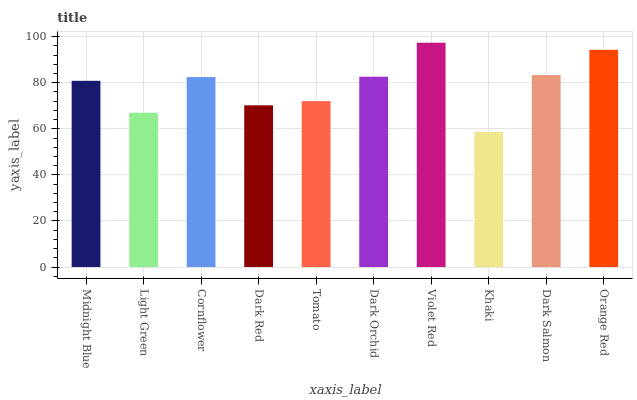Is Light Green the minimum?
Answer yes or no. No. Is Light Green the maximum?
Answer yes or no. No. Is Midnight Blue greater than Light Green?
Answer yes or no. Yes. Is Light Green less than Midnight Blue?
Answer yes or no. Yes. Is Light Green greater than Midnight Blue?
Answer yes or no. No. Is Midnight Blue less than Light Green?
Answer yes or no. No. Is Cornflower the high median?
Answer yes or no. Yes. Is Midnight Blue the low median?
Answer yes or no. Yes. Is Orange Red the high median?
Answer yes or no. No. Is Light Green the low median?
Answer yes or no. No. 